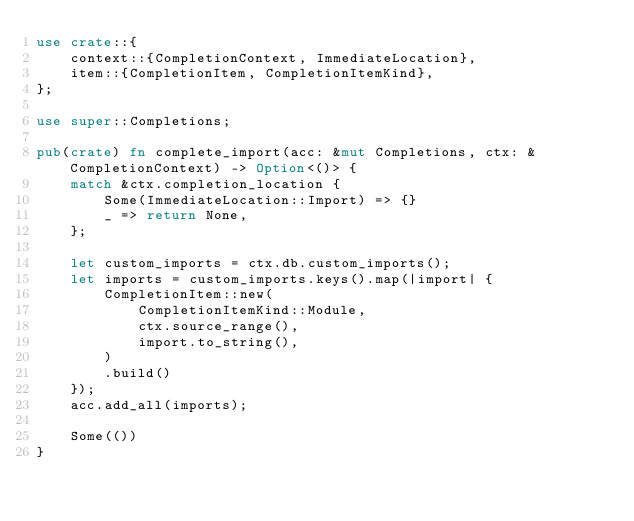<code> <loc_0><loc_0><loc_500><loc_500><_Rust_>use crate::{
    context::{CompletionContext, ImmediateLocation},
    item::{CompletionItem, CompletionItemKind},
};

use super::Completions;

pub(crate) fn complete_import(acc: &mut Completions, ctx: &CompletionContext) -> Option<()> {
    match &ctx.completion_location {
        Some(ImmediateLocation::Import) => {}
        _ => return None,
    };

    let custom_imports = ctx.db.custom_imports();
    let imports = custom_imports.keys().map(|import| {
        CompletionItem::new(
            CompletionItemKind::Module,
            ctx.source_range(),
            import.to_string(),
        )
        .build()
    });
    acc.add_all(imports);

    Some(())
}
</code> 